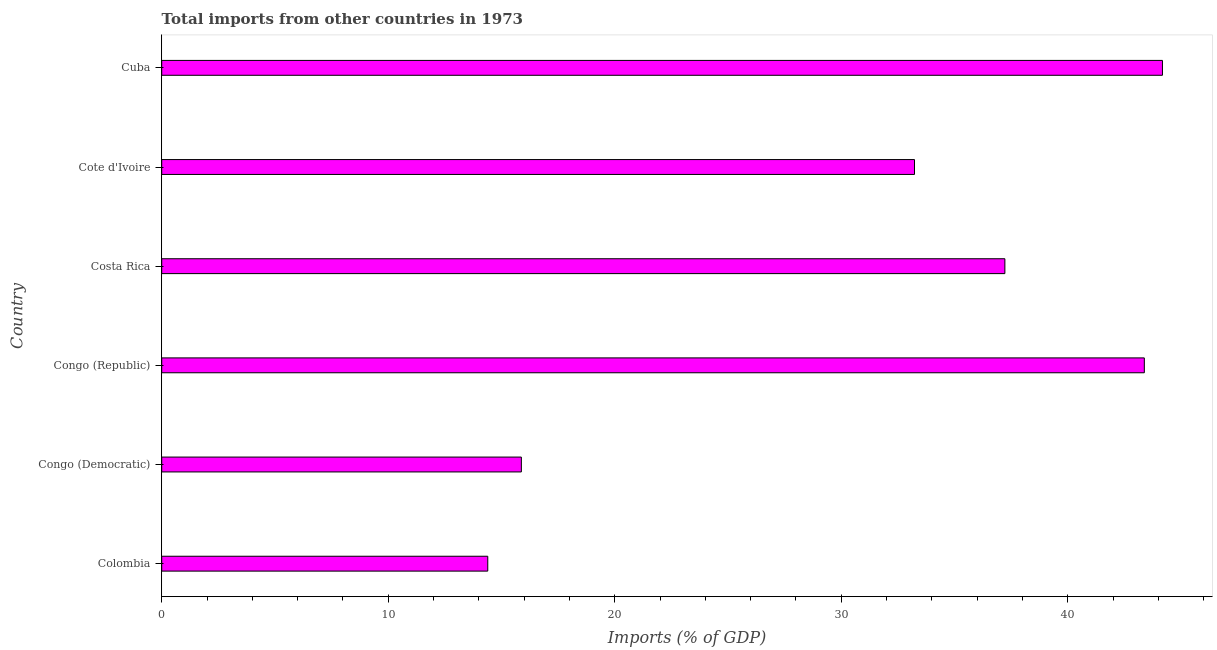Does the graph contain grids?
Your response must be concise. No. What is the title of the graph?
Make the answer very short. Total imports from other countries in 1973. What is the label or title of the X-axis?
Provide a succinct answer. Imports (% of GDP). What is the total imports in Colombia?
Offer a very short reply. 14.39. Across all countries, what is the maximum total imports?
Offer a very short reply. 44.18. Across all countries, what is the minimum total imports?
Your response must be concise. 14.39. In which country was the total imports maximum?
Provide a short and direct response. Cuba. What is the sum of the total imports?
Offer a terse response. 188.28. What is the difference between the total imports in Congo (Democratic) and Cote d'Ivoire?
Give a very brief answer. -17.36. What is the average total imports per country?
Your answer should be very brief. 31.38. What is the median total imports?
Provide a succinct answer. 35.23. In how many countries, is the total imports greater than 18 %?
Your response must be concise. 4. What is the ratio of the total imports in Colombia to that in Congo (Republic)?
Keep it short and to the point. 0.33. Is the total imports in Cote d'Ivoire less than that in Cuba?
Your response must be concise. Yes. Is the difference between the total imports in Colombia and Cote d'Ivoire greater than the difference between any two countries?
Your answer should be very brief. No. What is the difference between the highest and the second highest total imports?
Offer a very short reply. 0.8. What is the difference between the highest and the lowest total imports?
Offer a very short reply. 29.78. In how many countries, is the total imports greater than the average total imports taken over all countries?
Offer a very short reply. 4. Are all the bars in the graph horizontal?
Offer a terse response. Yes. How many countries are there in the graph?
Make the answer very short. 6. Are the values on the major ticks of X-axis written in scientific E-notation?
Give a very brief answer. No. What is the Imports (% of GDP) of Colombia?
Make the answer very short. 14.39. What is the Imports (% of GDP) of Congo (Democratic)?
Make the answer very short. 15.88. What is the Imports (% of GDP) in Congo (Republic)?
Your answer should be very brief. 43.38. What is the Imports (% of GDP) of Costa Rica?
Give a very brief answer. 37.22. What is the Imports (% of GDP) of Cote d'Ivoire?
Ensure brevity in your answer.  33.23. What is the Imports (% of GDP) in Cuba?
Ensure brevity in your answer.  44.18. What is the difference between the Imports (% of GDP) in Colombia and Congo (Democratic)?
Your response must be concise. -1.48. What is the difference between the Imports (% of GDP) in Colombia and Congo (Republic)?
Keep it short and to the point. -28.98. What is the difference between the Imports (% of GDP) in Colombia and Costa Rica?
Offer a terse response. -22.83. What is the difference between the Imports (% of GDP) in Colombia and Cote d'Ivoire?
Provide a short and direct response. -18.84. What is the difference between the Imports (% of GDP) in Colombia and Cuba?
Ensure brevity in your answer.  -29.78. What is the difference between the Imports (% of GDP) in Congo (Democratic) and Congo (Republic)?
Give a very brief answer. -27.5. What is the difference between the Imports (% of GDP) in Congo (Democratic) and Costa Rica?
Provide a short and direct response. -21.35. What is the difference between the Imports (% of GDP) in Congo (Democratic) and Cote d'Ivoire?
Your answer should be compact. -17.36. What is the difference between the Imports (% of GDP) in Congo (Democratic) and Cuba?
Offer a terse response. -28.3. What is the difference between the Imports (% of GDP) in Congo (Republic) and Costa Rica?
Your response must be concise. 6.16. What is the difference between the Imports (% of GDP) in Congo (Republic) and Cote d'Ivoire?
Give a very brief answer. 10.15. What is the difference between the Imports (% of GDP) in Congo (Republic) and Cuba?
Your response must be concise. -0.8. What is the difference between the Imports (% of GDP) in Costa Rica and Cote d'Ivoire?
Provide a short and direct response. 3.99. What is the difference between the Imports (% of GDP) in Costa Rica and Cuba?
Give a very brief answer. -6.96. What is the difference between the Imports (% of GDP) in Cote d'Ivoire and Cuba?
Give a very brief answer. -10.95. What is the ratio of the Imports (% of GDP) in Colombia to that in Congo (Democratic)?
Offer a very short reply. 0.91. What is the ratio of the Imports (% of GDP) in Colombia to that in Congo (Republic)?
Make the answer very short. 0.33. What is the ratio of the Imports (% of GDP) in Colombia to that in Costa Rica?
Ensure brevity in your answer.  0.39. What is the ratio of the Imports (% of GDP) in Colombia to that in Cote d'Ivoire?
Offer a terse response. 0.43. What is the ratio of the Imports (% of GDP) in Colombia to that in Cuba?
Provide a short and direct response. 0.33. What is the ratio of the Imports (% of GDP) in Congo (Democratic) to that in Congo (Republic)?
Your response must be concise. 0.37. What is the ratio of the Imports (% of GDP) in Congo (Democratic) to that in Costa Rica?
Keep it short and to the point. 0.43. What is the ratio of the Imports (% of GDP) in Congo (Democratic) to that in Cote d'Ivoire?
Your answer should be very brief. 0.48. What is the ratio of the Imports (% of GDP) in Congo (Democratic) to that in Cuba?
Give a very brief answer. 0.36. What is the ratio of the Imports (% of GDP) in Congo (Republic) to that in Costa Rica?
Offer a very short reply. 1.17. What is the ratio of the Imports (% of GDP) in Congo (Republic) to that in Cote d'Ivoire?
Make the answer very short. 1.3. What is the ratio of the Imports (% of GDP) in Costa Rica to that in Cote d'Ivoire?
Keep it short and to the point. 1.12. What is the ratio of the Imports (% of GDP) in Costa Rica to that in Cuba?
Your answer should be compact. 0.84. What is the ratio of the Imports (% of GDP) in Cote d'Ivoire to that in Cuba?
Your answer should be compact. 0.75. 